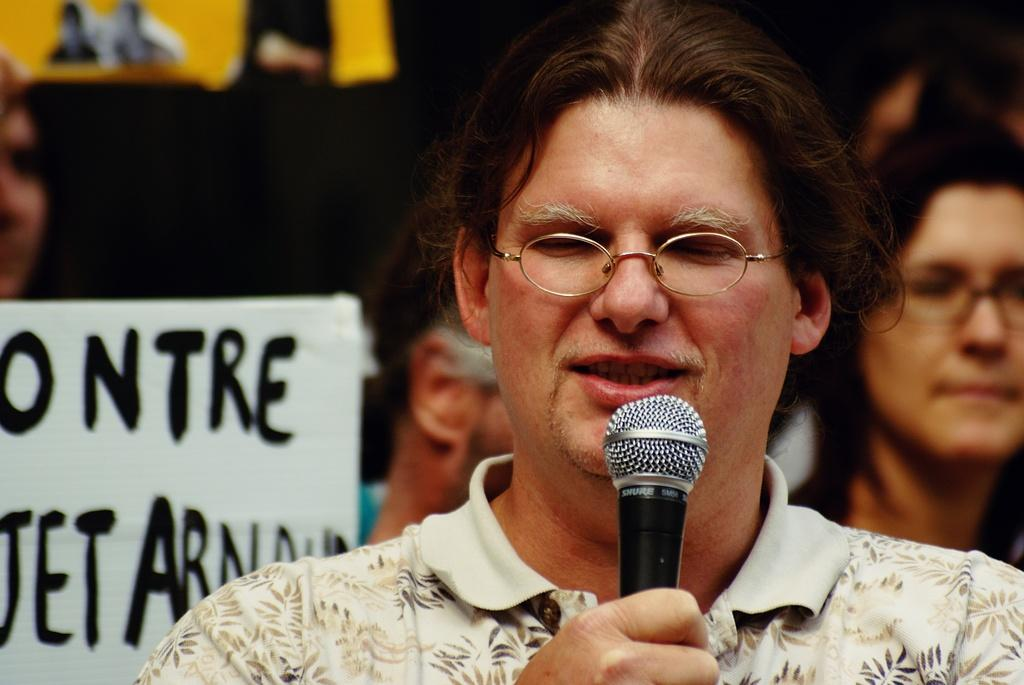What is the person in the image doing? The person in the image is talking. What is the talking person holding? The talking person is holding a microphone. Can you describe the people behind the talking person? There are other people behind the talking person. What is present in the image besides the people? There is a banner in the image. What can be observed about the talking person's appearance? The talking person is wearing spectacles and a t-shirt. What type of door can be seen sparking in the image? There is no door or spark present in the image. 